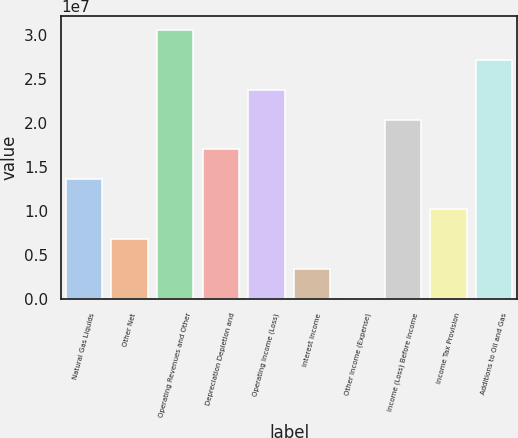Convert chart. <chart><loc_0><loc_0><loc_500><loc_500><bar_chart><fcel>Natural Gas Liquids<fcel>Other Net<fcel>Operating Revenues and Other<fcel>Depreciation Depletion and<fcel>Operating Income (Loss)<fcel>Interest Income<fcel>Other Income (Expense)<fcel>Income (Loss) Before Income<fcel>Income Tax Provision<fcel>Additions to Oil and Gas<nl><fcel>1.35769e+07<fcel>6.79102e+06<fcel>3.05415e+07<fcel>1.69698e+07<fcel>2.37557e+07<fcel>3.39809e+06<fcel>5158<fcel>2.03627e+07<fcel>1.0184e+07<fcel>2.71486e+07<nl></chart> 